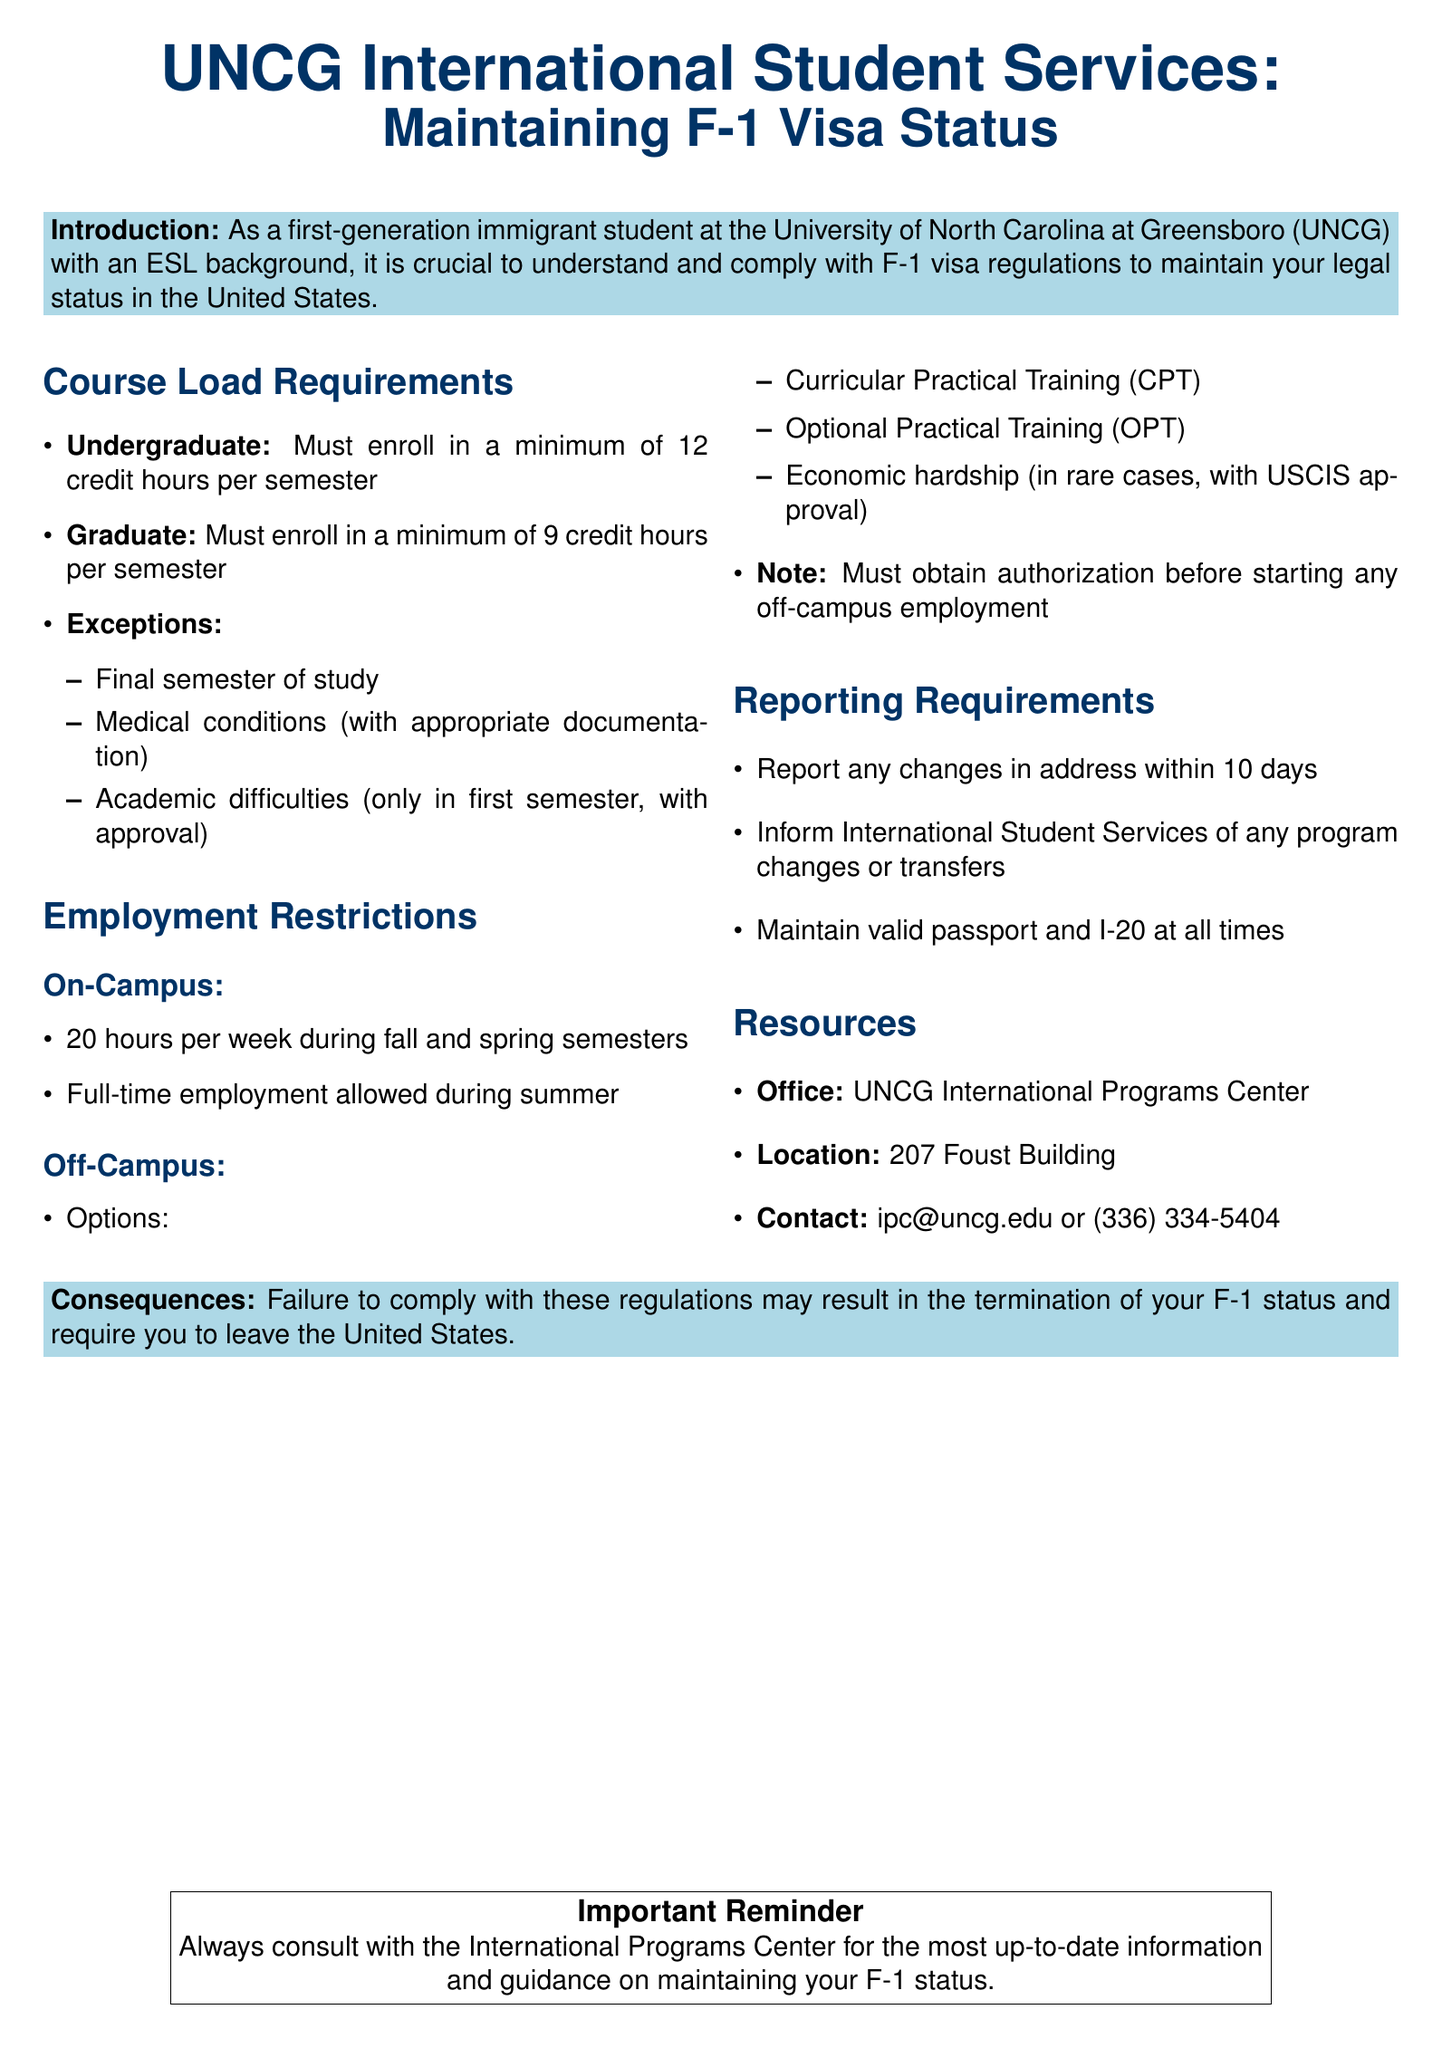What is the minimum credit hour requirement for undergraduate students? The document states that undergraduate students must enroll in a minimum of 12 credit hours per semester.
Answer: 12 credit hours What is the contact email for the International Programs Center? The contact email for the International Programs Center is provided as ipc@uncg.edu.
Answer: ipc@uncg.edu How many hours of on-campus employment are allowed during fall and spring semesters? The document specifies that on-campus employment is limited to 20 hours per week during fall and spring semesters.
Answer: 20 hours What are two options for off-campus employment? The document lists Curricular Practical Training (CPT) and Optional Practical Training (OPT) as two options for off-campus employment.
Answer: CPT, OPT What should you do if your address changes? The document requires reporting any changes in address within 10 days.
Answer: Report within 10 days Under what circumstances can an undergraduate student enroll in fewer than 12 credit hours? The document mentions exceptions for the final semester, medical conditions with documentation, or academic difficulties with approval in the first semester.
Answer: Final semester, medical conditions, academic difficulties What is the location of the International Programs Center? The document indicates that the International Programs Center is located at 207 Foust Building.
Answer: 207 Foust Building What may happen if you fail to comply with the regulations? The document warns that failure to comply may result in the termination of your F-1 status and require leaving the United States.
Answer: Termination of F-1 status Which semester allows full-time on-campus employment? The document states that full-time employment is allowed during the summer semester.
Answer: Summer 